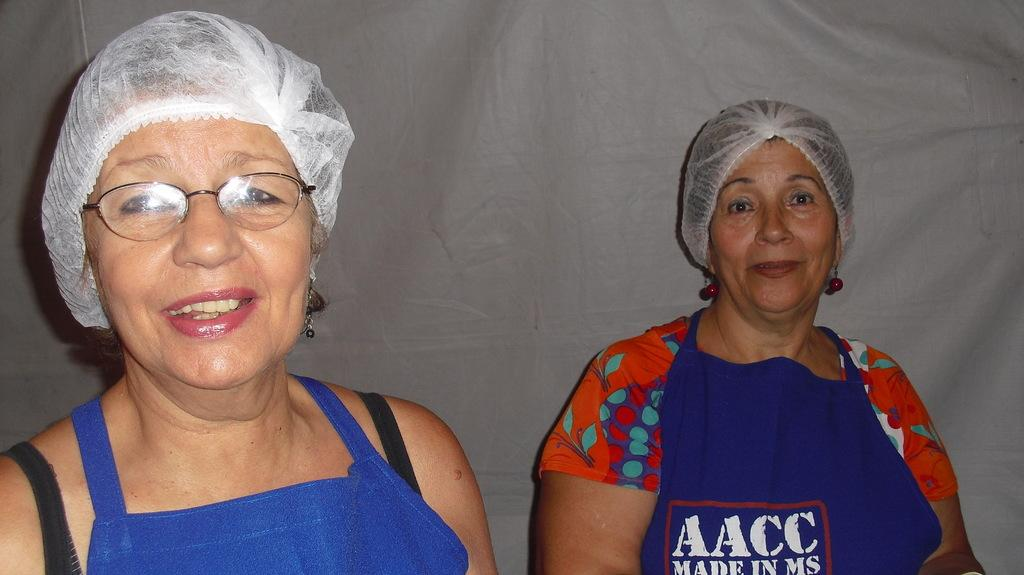How many people are in the image? There are two women in the image. What is the facial expression of the women? The women are smiling. What are the women wearing in the image? Both women are wearing aprons. What color are the aprons? The aprons are blue in color. What is the color of the background in the image? The background of the image is white. What type of volleyball game is being played in the image? There is no volleyball game present in the image. Can you describe the rhythm of the whip in the image? There is no whip present in the image, so it is not possible to describe its rhythm. 